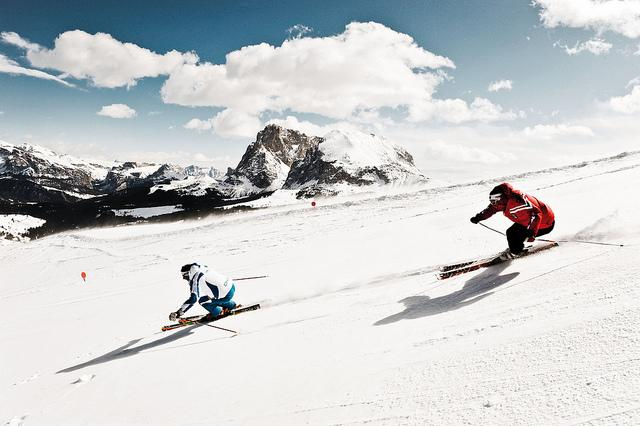What kind of skis are the two using in this mountain range?

Choices:
A) country
B) racing
C) alpine
D) trick racing 